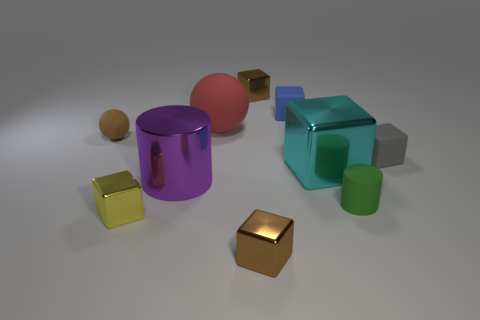Which object stands out the most to you, and why? The purple cylinder with the cut-through hole stands out most prominently due to its unique shape and the reflective purple surface, which is quite eye-catching compared to the other objects in the scene. What could be the context or function of these objects? These objects might represent geometric models typically used in 3D design or rendering software to showcase various shapes, materials, and lighting effects for educational or demonstration purposes. 